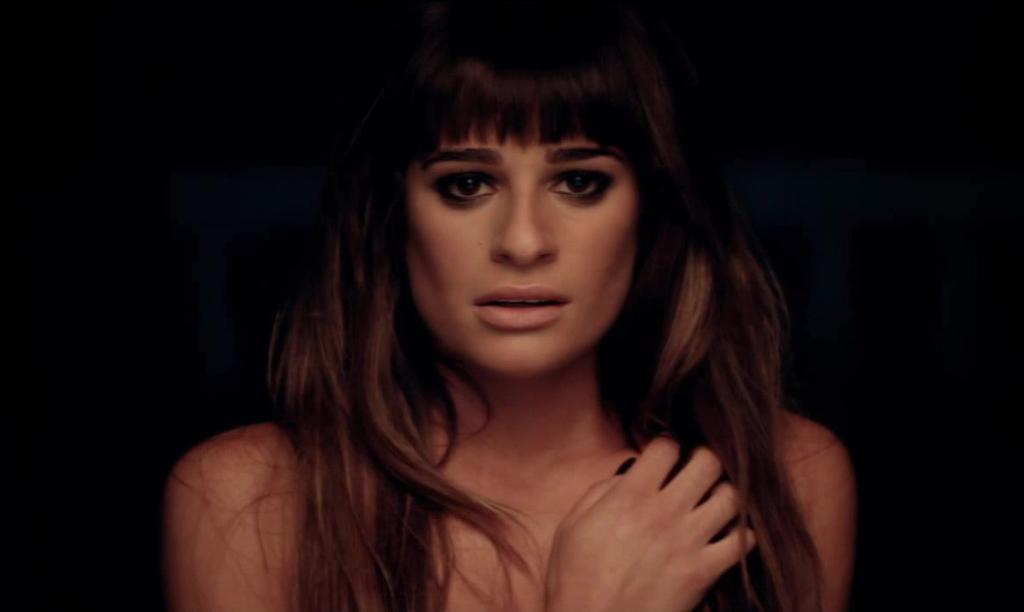Who is the main subject in the image? There is a woman in the image. What can be observed about the background of the image? The background of the image is dark. What type of power does the art in the image possess? There is no art present in the image, so it cannot possess any power. 